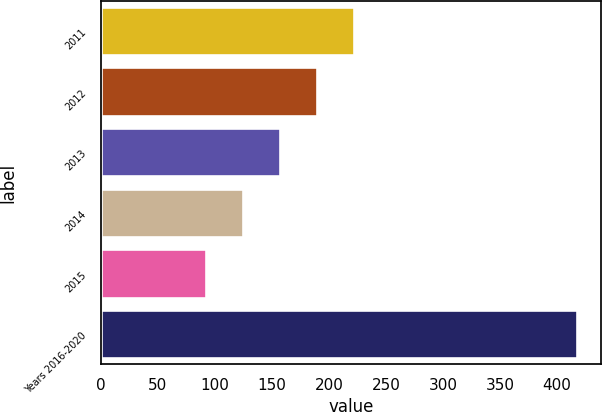<chart> <loc_0><loc_0><loc_500><loc_500><bar_chart><fcel>2011<fcel>2012<fcel>2013<fcel>2014<fcel>2015<fcel>Years 2016-2020<nl><fcel>222.4<fcel>189.8<fcel>157.2<fcel>124.6<fcel>92<fcel>418<nl></chart> 